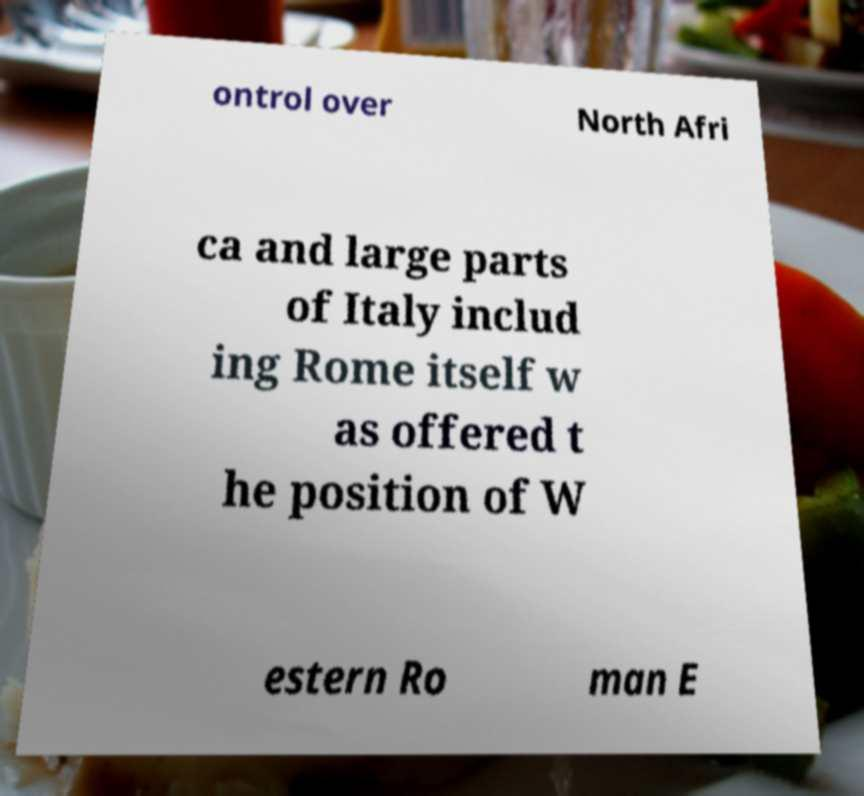Please read and relay the text visible in this image. What does it say? ontrol over North Afri ca and large parts of Italy includ ing Rome itself w as offered t he position of W estern Ro man E 